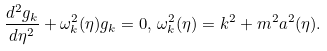<formula> <loc_0><loc_0><loc_500><loc_500>\frac { d ^ { 2 } g _ { k } } { d \eta ^ { 2 } } + \omega _ { k } ^ { 2 } ( \eta ) g _ { k } = 0 , \, \omega _ { k } ^ { 2 } ( \eta ) = k ^ { 2 } + m ^ { 2 } a ^ { 2 } ( \eta ) .</formula> 